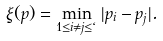<formula> <loc_0><loc_0><loc_500><loc_500>\xi ( p ) = \min _ { 1 \leq i \neq j \leq \ell } | p _ { i } - p _ { j } | .</formula> 